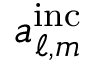Convert formula to latex. <formula><loc_0><loc_0><loc_500><loc_500>a _ { \ell , m } ^ { i n c }</formula> 